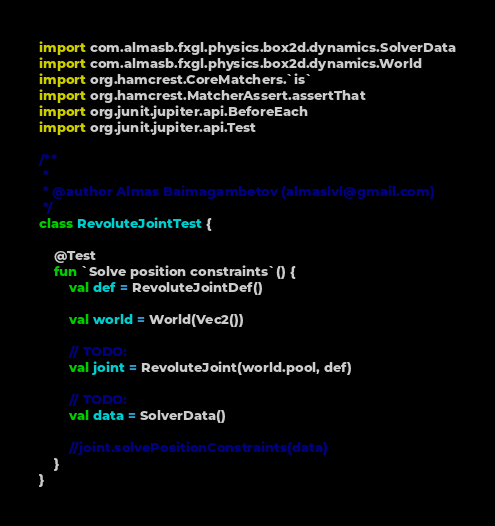<code> <loc_0><loc_0><loc_500><loc_500><_Kotlin_>import com.almasb.fxgl.physics.box2d.dynamics.SolverData
import com.almasb.fxgl.physics.box2d.dynamics.World
import org.hamcrest.CoreMatchers.`is`
import org.hamcrest.MatcherAssert.assertThat
import org.junit.jupiter.api.BeforeEach
import org.junit.jupiter.api.Test

/**
 *
 * @author Almas Baimagambetov (almaslvl@gmail.com)
 */
class RevoluteJointTest {

    @Test
    fun `Solve position constraints`() {
        val def = RevoluteJointDef()

        val world = World(Vec2())

        // TODO:
        val joint = RevoluteJoint(world.pool, def)

        // TODO:
        val data = SolverData()

        //joint.solvePositionConstraints(data)
    }
}</code> 